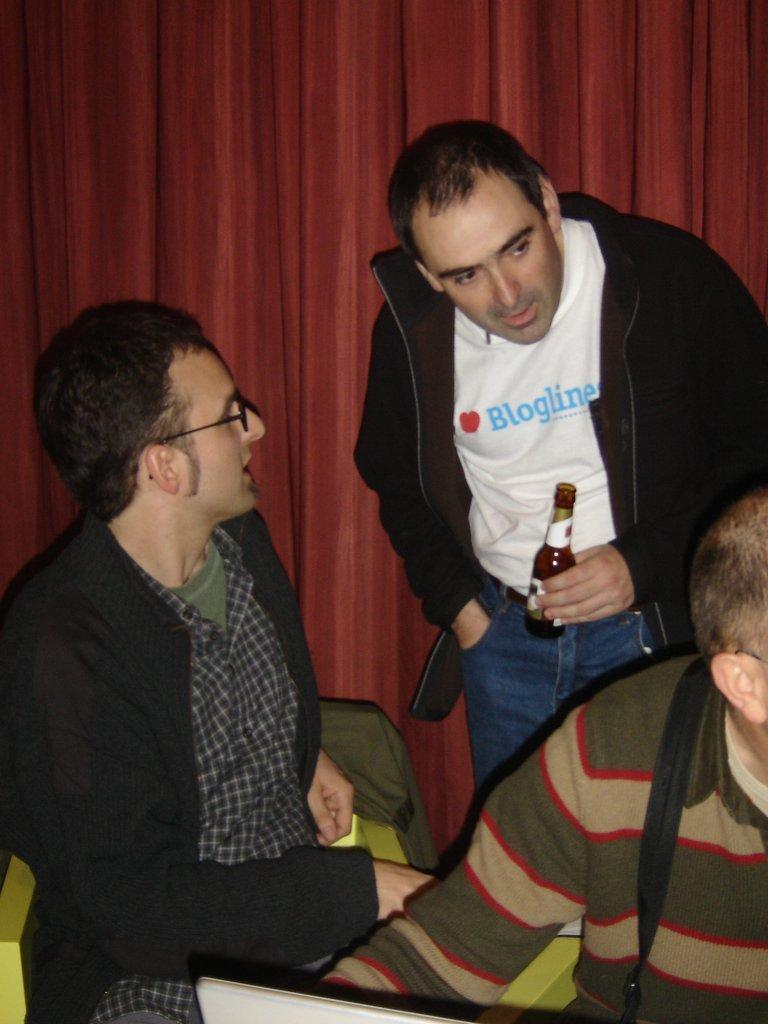How many people are sitting in the image? There are two people sitting in the image. What is the man in the image doing? The man is standing in the image and holding a wine bottle. What can be seen in the background of the image? There is a curtain in the background of the image. What type of silk fabric is being used to make the uncle's suit in the image? There is no uncle present in the image, nor is there any mention of a suit or silk fabric. 